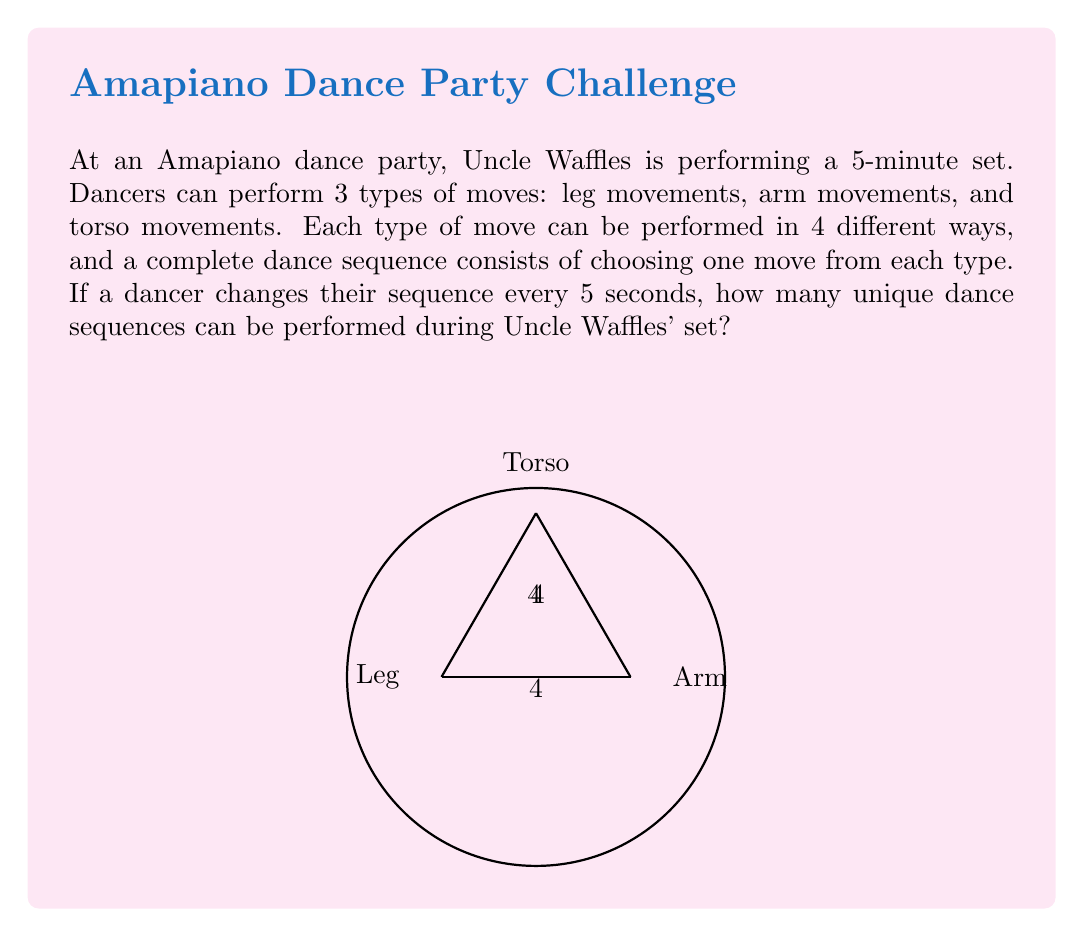What is the answer to this math problem? Let's break this down step-by-step:

1) First, let's calculate how many unique dance sequences can be performed at any given moment:
   - For leg movements: 4 options
   - For arm movements: 4 options
   - For torso movements: 4 options
   
   Total unique combinations = $4 \times 4 \times 4 = 64$

2) Now, let's calculate how many 5-second intervals are in a 5-minute set:
   $$\text{Number of intervals} = \frac{5 \text{ minutes} \times 60 \text{ seconds/minute}}{5 \text{ seconds/interval}} = 60 \text{ intervals}$$

3) In each interval, a dancer can choose any of the 64 unique sequences. This is equivalent to making 60 independent choices, each with 64 options.

4) The total number of unique dance sequences over the entire set is therefore:
   $$64^{60}$$

5) This is a very large number. We can express it in scientific notation:
   $$64^{60} \approx 7.922 \times 10^{108}$$

Thus, during Uncle Waffles' 5-minute Amapiano set, dancers could theoretically perform approximately $7.922 \times 10^{108}$ unique dance sequences.
Answer: $7.922 \times 10^{108}$ 